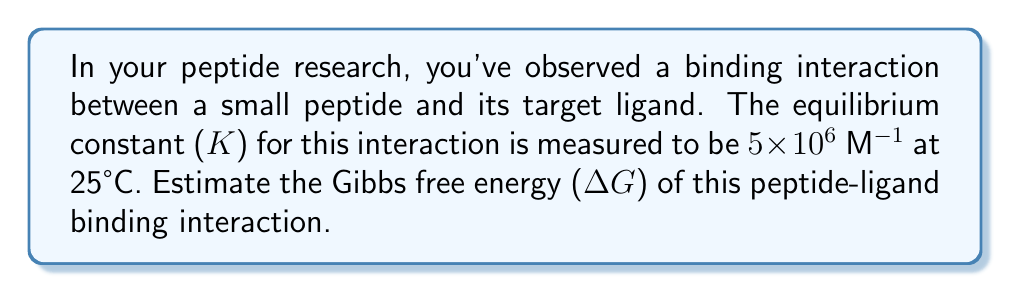Could you help me with this problem? To estimate the Gibbs free energy (ΔG) of the peptide-ligand binding interaction, we can use the relationship between ΔG and the equilibrium constant K. The steps are as follows:

1. Recall the equation relating ΔG and K:
   $$\Delta G = -RT \ln K$$
   Where:
   - R is the gas constant (8.314 J/mol·K)
   - T is the temperature in Kelvin
   - K is the equilibrium constant

2. Convert the temperature from Celsius to Kelvin:
   T = 25°C + 273.15 = 298.15 K

3. Convert the equilibrium constant to its natural logarithm:
   $$\ln K = \ln (5 \times 10^6) = \ln 5 + \ln 10^6 = 1.61 + 13.82 = 15.43$$

4. Substitute the values into the equation:
   $$\Delta G = -(8.314 \text{ J/mol·K})(298.15 \text{ K})(15.43)$$

5. Calculate the result:
   $$\Delta G = -38,230 \text{ J/mol} = -38.23 \text{ kJ/mol}$$

The negative value indicates that the binding interaction is spontaneous and favorable.
Answer: $-38.23 \text{ kJ/mol}$ 